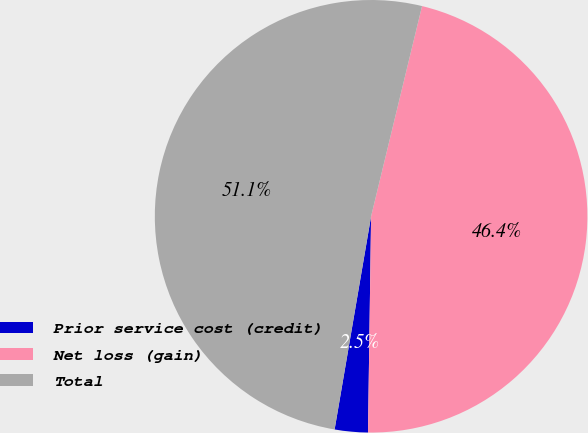Convert chart to OTSL. <chart><loc_0><loc_0><loc_500><loc_500><pie_chart><fcel>Prior service cost (credit)<fcel>Net loss (gain)<fcel>Total<nl><fcel>2.47%<fcel>46.44%<fcel>51.08%<nl></chart> 